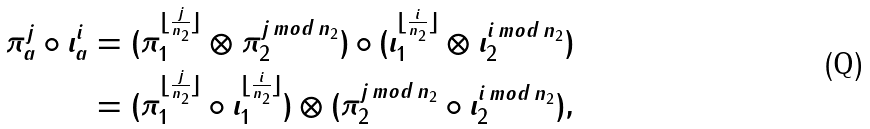Convert formula to latex. <formula><loc_0><loc_0><loc_500><loc_500>\pi _ { a } ^ { j } \circ \iota _ { a } ^ { i } & = ( \pi _ { 1 } ^ { \lfloor \frac { j } { n _ { 2 } } \rfloor } \otimes \pi _ { 2 } ^ { j \, m o d \, n _ { 2 } } ) \circ ( \iota _ { 1 } ^ { \lfloor \frac { i } { n _ { 2 } } \rfloor } \otimes \iota _ { 2 } ^ { i \, m o d \, n _ { 2 } } ) \\ & = ( \pi _ { 1 } ^ { \lfloor \frac { j } { n _ { 2 } } \rfloor } \circ \iota _ { 1 } ^ { \lfloor \frac { i } { n _ { 2 } } \rfloor } ) \otimes ( \pi _ { 2 } ^ { j \, m o d \, n _ { 2 } } \circ \iota _ { 2 } ^ { i \, m o d \, n _ { 2 } } ) ,</formula> 